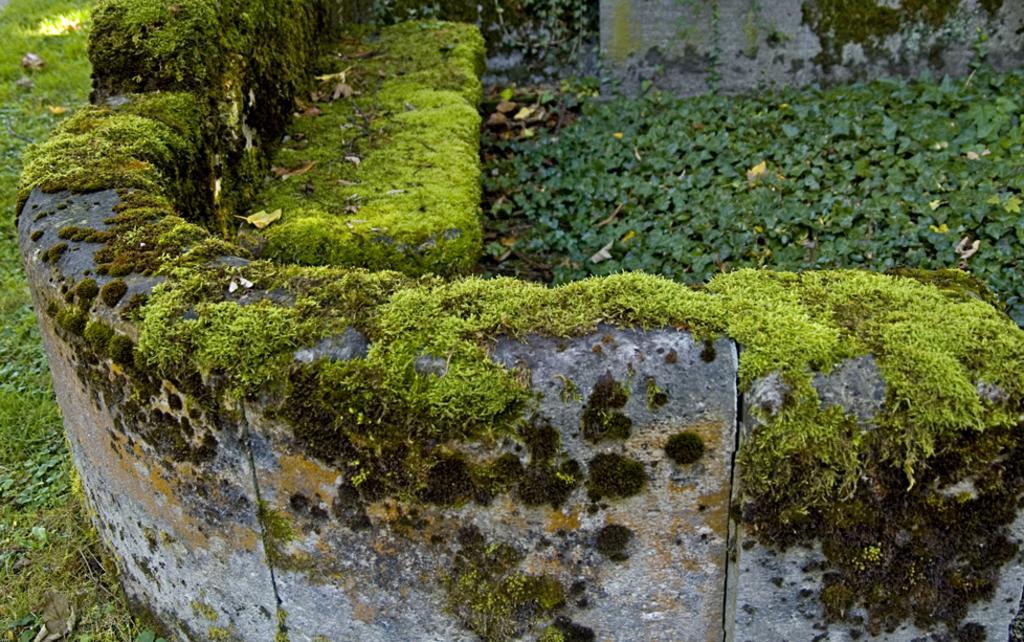Could you give a brief overview of what you see in this image? In this image there is a wall. There is grass and algae on the wall. To the left there's grass on the ground. To the right there are plants. 